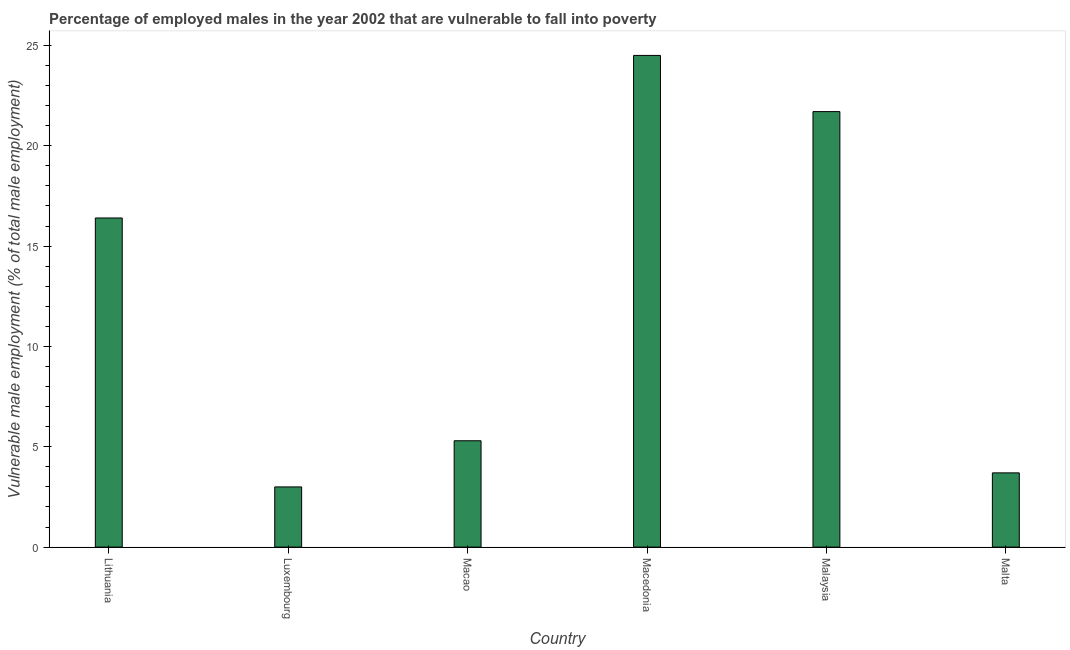What is the title of the graph?
Your answer should be compact. Percentage of employed males in the year 2002 that are vulnerable to fall into poverty. What is the label or title of the X-axis?
Your answer should be compact. Country. What is the label or title of the Y-axis?
Offer a terse response. Vulnerable male employment (% of total male employment). What is the percentage of employed males who are vulnerable to fall into poverty in Lithuania?
Offer a terse response. 16.4. Across all countries, what is the maximum percentage of employed males who are vulnerable to fall into poverty?
Keep it short and to the point. 24.5. Across all countries, what is the minimum percentage of employed males who are vulnerable to fall into poverty?
Your answer should be compact. 3. In which country was the percentage of employed males who are vulnerable to fall into poverty maximum?
Your response must be concise. Macedonia. In which country was the percentage of employed males who are vulnerable to fall into poverty minimum?
Make the answer very short. Luxembourg. What is the sum of the percentage of employed males who are vulnerable to fall into poverty?
Give a very brief answer. 74.6. What is the average percentage of employed males who are vulnerable to fall into poverty per country?
Offer a very short reply. 12.43. What is the median percentage of employed males who are vulnerable to fall into poverty?
Keep it short and to the point. 10.85. What is the ratio of the percentage of employed males who are vulnerable to fall into poverty in Luxembourg to that in Malaysia?
Give a very brief answer. 0.14. Is the percentage of employed males who are vulnerable to fall into poverty in Macedonia less than that in Malaysia?
Your answer should be compact. No. How many bars are there?
Provide a short and direct response. 6. Are all the bars in the graph horizontal?
Your response must be concise. No. How many countries are there in the graph?
Provide a short and direct response. 6. What is the difference between two consecutive major ticks on the Y-axis?
Provide a succinct answer. 5. What is the Vulnerable male employment (% of total male employment) of Lithuania?
Your answer should be very brief. 16.4. What is the Vulnerable male employment (% of total male employment) of Macao?
Your answer should be very brief. 5.3. What is the Vulnerable male employment (% of total male employment) in Macedonia?
Offer a terse response. 24.5. What is the Vulnerable male employment (% of total male employment) in Malaysia?
Provide a short and direct response. 21.7. What is the Vulnerable male employment (% of total male employment) in Malta?
Make the answer very short. 3.7. What is the difference between the Vulnerable male employment (% of total male employment) in Lithuania and Luxembourg?
Your answer should be compact. 13.4. What is the difference between the Vulnerable male employment (% of total male employment) in Lithuania and Macao?
Your response must be concise. 11.1. What is the difference between the Vulnerable male employment (% of total male employment) in Lithuania and Malaysia?
Ensure brevity in your answer.  -5.3. What is the difference between the Vulnerable male employment (% of total male employment) in Luxembourg and Macedonia?
Your answer should be very brief. -21.5. What is the difference between the Vulnerable male employment (% of total male employment) in Luxembourg and Malaysia?
Your answer should be very brief. -18.7. What is the difference between the Vulnerable male employment (% of total male employment) in Luxembourg and Malta?
Offer a terse response. -0.7. What is the difference between the Vulnerable male employment (% of total male employment) in Macao and Macedonia?
Offer a terse response. -19.2. What is the difference between the Vulnerable male employment (% of total male employment) in Macao and Malaysia?
Give a very brief answer. -16.4. What is the difference between the Vulnerable male employment (% of total male employment) in Macao and Malta?
Offer a terse response. 1.6. What is the difference between the Vulnerable male employment (% of total male employment) in Macedonia and Malaysia?
Provide a succinct answer. 2.8. What is the difference between the Vulnerable male employment (% of total male employment) in Macedonia and Malta?
Make the answer very short. 20.8. What is the difference between the Vulnerable male employment (% of total male employment) in Malaysia and Malta?
Make the answer very short. 18. What is the ratio of the Vulnerable male employment (% of total male employment) in Lithuania to that in Luxembourg?
Keep it short and to the point. 5.47. What is the ratio of the Vulnerable male employment (% of total male employment) in Lithuania to that in Macao?
Provide a short and direct response. 3.09. What is the ratio of the Vulnerable male employment (% of total male employment) in Lithuania to that in Macedonia?
Keep it short and to the point. 0.67. What is the ratio of the Vulnerable male employment (% of total male employment) in Lithuania to that in Malaysia?
Your response must be concise. 0.76. What is the ratio of the Vulnerable male employment (% of total male employment) in Lithuania to that in Malta?
Give a very brief answer. 4.43. What is the ratio of the Vulnerable male employment (% of total male employment) in Luxembourg to that in Macao?
Your answer should be very brief. 0.57. What is the ratio of the Vulnerable male employment (% of total male employment) in Luxembourg to that in Macedonia?
Keep it short and to the point. 0.12. What is the ratio of the Vulnerable male employment (% of total male employment) in Luxembourg to that in Malaysia?
Offer a very short reply. 0.14. What is the ratio of the Vulnerable male employment (% of total male employment) in Luxembourg to that in Malta?
Give a very brief answer. 0.81. What is the ratio of the Vulnerable male employment (% of total male employment) in Macao to that in Macedonia?
Provide a short and direct response. 0.22. What is the ratio of the Vulnerable male employment (% of total male employment) in Macao to that in Malaysia?
Ensure brevity in your answer.  0.24. What is the ratio of the Vulnerable male employment (% of total male employment) in Macao to that in Malta?
Offer a terse response. 1.43. What is the ratio of the Vulnerable male employment (% of total male employment) in Macedonia to that in Malaysia?
Your response must be concise. 1.13. What is the ratio of the Vulnerable male employment (% of total male employment) in Macedonia to that in Malta?
Your response must be concise. 6.62. What is the ratio of the Vulnerable male employment (% of total male employment) in Malaysia to that in Malta?
Ensure brevity in your answer.  5.87. 